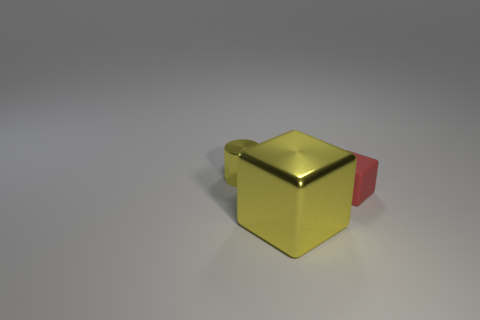Add 3 purple cylinders. How many objects exist? 6 Subtract all cylinders. How many objects are left? 2 Subtract 0 green spheres. How many objects are left? 3 Subtract all big metal cubes. Subtract all tiny metal objects. How many objects are left? 1 Add 1 big yellow things. How many big yellow things are left? 2 Add 3 small brown matte cylinders. How many small brown matte cylinders exist? 3 